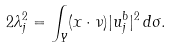<formula> <loc_0><loc_0><loc_500><loc_500>2 \lambda _ { j } ^ { 2 } = \int _ { Y } ( x \cdot \nu ) | u _ { j } ^ { b } | ^ { 2 } \, d \sigma .</formula> 